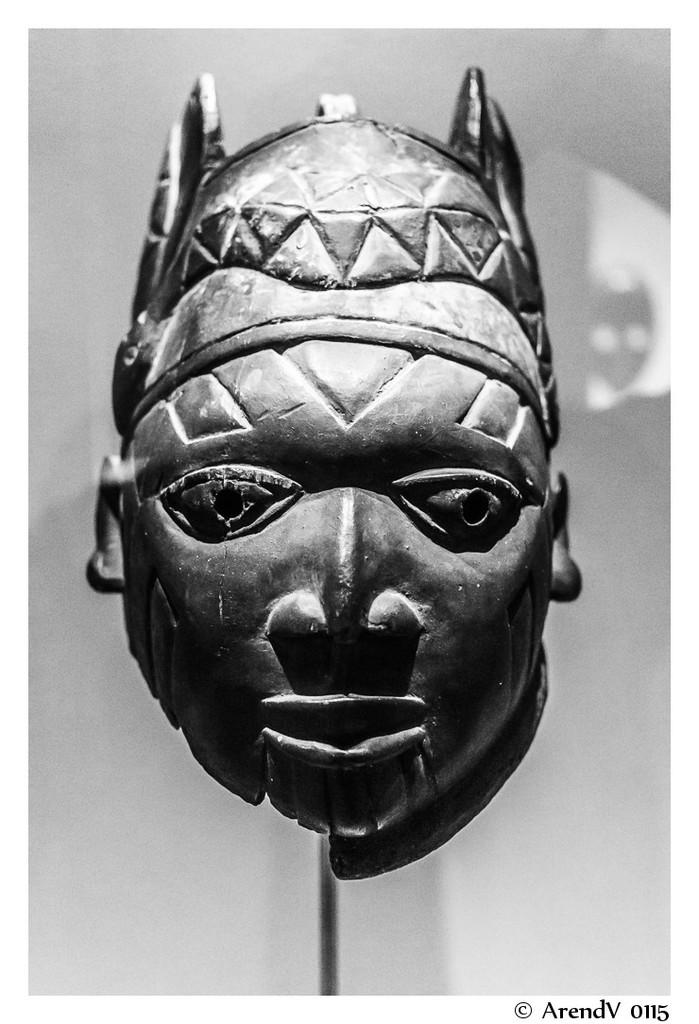What is the main subject of the image? There is a sculpture of a human face in the image. Can you describe the sculpture in more detail? The sculpture is of a human face, but the specific features or materials used cannot be determined from the image alone. How many quarters are used to create the current in the image? There are no quarters or currents present in the image; it features a sculpture of a human face. 